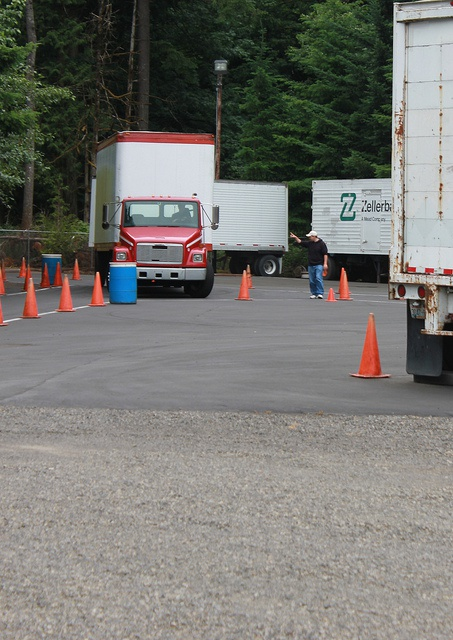Describe the objects in this image and their specific colors. I can see truck in darkgreen, lightgray, gray, black, and darkgray tones, truck in darkgreen, lightgray, darkgray, and black tones, truck in darkgreen, darkgray, black, and lightgray tones, people in darkgreen, black, navy, blue, and gray tones, and people in darkgreen and gray tones in this image. 